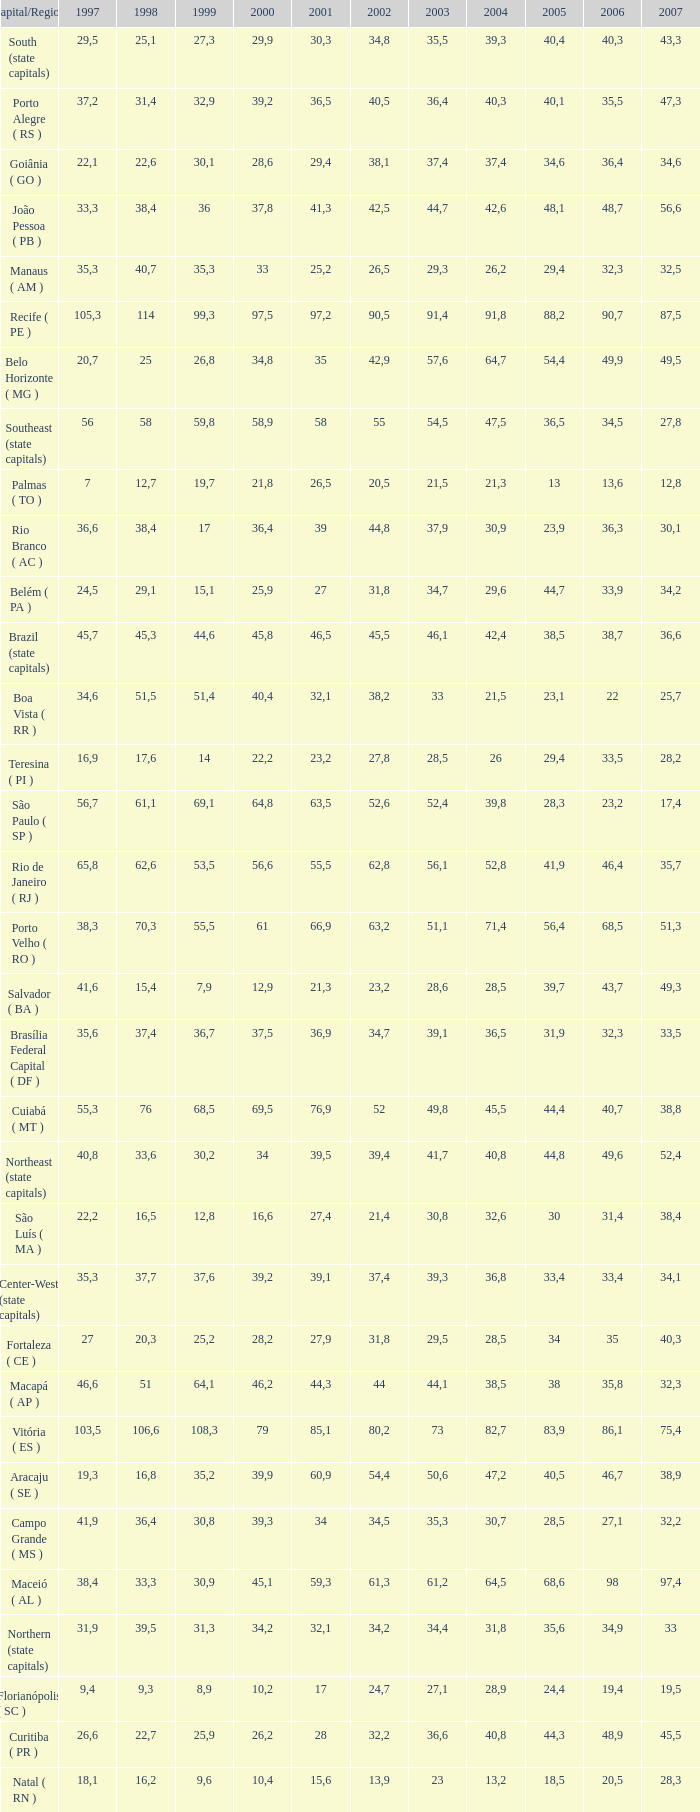What is the average 2000 that has a 1997 greater than 34,6, a 2006 greater than 38,7, and a 2998 less than 76? 41.92. 